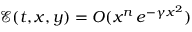<formula> <loc_0><loc_0><loc_500><loc_500>{ \mathcal { E } } ( t , x , y ) = O ( x ^ { n } \, e ^ { - \gamma x ^ { 2 } } )</formula> 